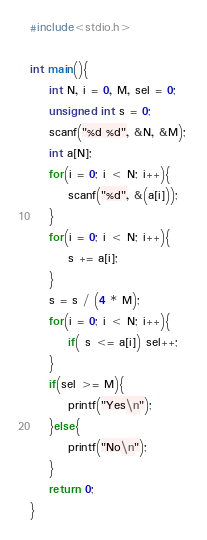Convert code to text. <code><loc_0><loc_0><loc_500><loc_500><_C_>#include<stdio.h>

int main(){
	int N, i = 0, M, sel = 0;
	unsigned int s = 0;
	scanf("%d %d", &N, &M);
	int a[N];
	for(i = 0; i < N; i++){	
		scanf("%d", &(a[i]));
	}
	for(i = 0; i < N; i++){
		s += a[i];
	}
	s = s / (4 * M);
	for(i = 0; i < N; i++){	
		if( s <= a[i]) sel++;
	}
	if(sel >= M){
		printf("Yes\n");
	}else{
		printf("No\n");
	}
	return 0;
}</code> 